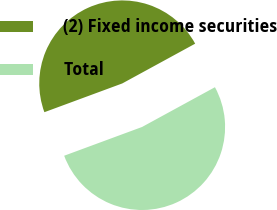Convert chart. <chart><loc_0><loc_0><loc_500><loc_500><pie_chart><fcel>(2) Fixed income securities<fcel>Total<nl><fcel>47.68%<fcel>52.32%<nl></chart> 